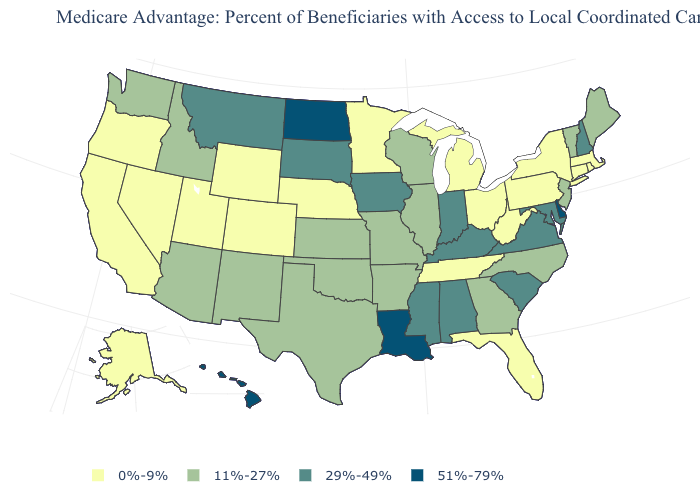What is the lowest value in the USA?
Keep it brief. 0%-9%. What is the value of Pennsylvania?
Keep it brief. 0%-9%. Name the states that have a value in the range 0%-9%?
Write a very short answer. California, Colorado, Connecticut, Florida, Massachusetts, Michigan, Minnesota, Nebraska, Nevada, New York, Ohio, Oregon, Pennsylvania, Rhode Island, Alaska, Tennessee, Utah, West Virginia, Wyoming. Does the map have missing data?
Keep it brief. No. What is the highest value in the USA?
Be succinct. 51%-79%. What is the value of West Virginia?
Answer briefly. 0%-9%. Name the states that have a value in the range 11%-27%?
Give a very brief answer. Georgia, Idaho, Illinois, Kansas, Maine, Missouri, North Carolina, New Jersey, New Mexico, Oklahoma, Texas, Vermont, Washington, Wisconsin, Arkansas, Arizona. Among the states that border New Mexico , does Colorado have the highest value?
Keep it brief. No. Does Minnesota have the highest value in the MidWest?
Be succinct. No. What is the lowest value in the West?
Write a very short answer. 0%-9%. What is the value of Kansas?
Quick response, please. 11%-27%. What is the value of Virginia?
Concise answer only. 29%-49%. Name the states that have a value in the range 51%-79%?
Be succinct. Delaware, Hawaii, Louisiana, North Dakota. What is the value of Oregon?
Answer briefly. 0%-9%. Name the states that have a value in the range 51%-79%?
Keep it brief. Delaware, Hawaii, Louisiana, North Dakota. 